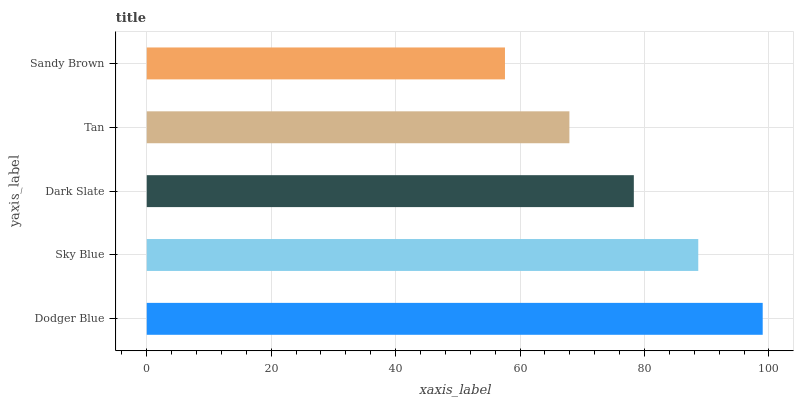Is Sandy Brown the minimum?
Answer yes or no. Yes. Is Dodger Blue the maximum?
Answer yes or no. Yes. Is Sky Blue the minimum?
Answer yes or no. No. Is Sky Blue the maximum?
Answer yes or no. No. Is Dodger Blue greater than Sky Blue?
Answer yes or no. Yes. Is Sky Blue less than Dodger Blue?
Answer yes or no. Yes. Is Sky Blue greater than Dodger Blue?
Answer yes or no. No. Is Dodger Blue less than Sky Blue?
Answer yes or no. No. Is Dark Slate the high median?
Answer yes or no. Yes. Is Dark Slate the low median?
Answer yes or no. Yes. Is Sandy Brown the high median?
Answer yes or no. No. Is Sandy Brown the low median?
Answer yes or no. No. 